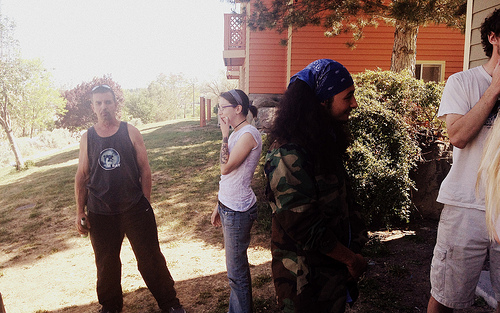<image>
Is there a plant to the left of the person? No. The plant is not to the left of the person. From this viewpoint, they have a different horizontal relationship. Is the woman behind the girl? No. The woman is not behind the girl. From this viewpoint, the woman appears to be positioned elsewhere in the scene. 